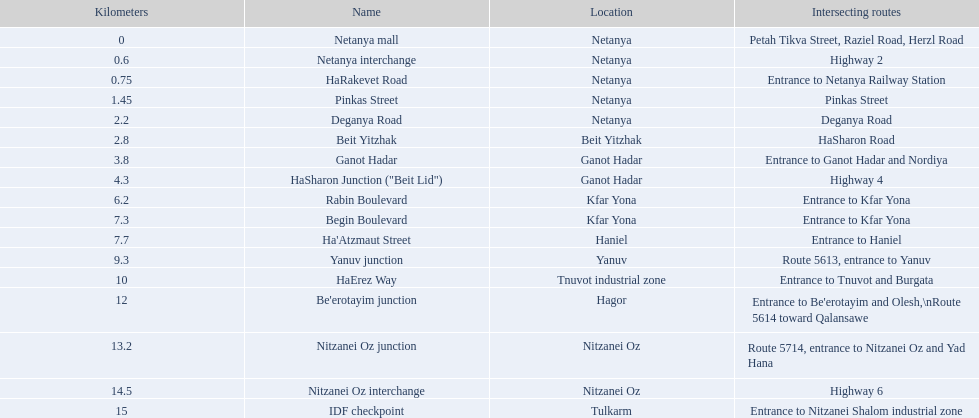Which part has the greatest length? IDF checkpoint. Would you be able to parse every entry in this table? {'header': ['Kilometers', 'Name', 'Location', 'Intersecting routes'], 'rows': [['0', 'Netanya mall', 'Netanya', 'Petah Tikva Street, Raziel Road, Herzl Road'], ['0.6', 'Netanya interchange', 'Netanya', 'Highway 2'], ['0.75', 'HaRakevet Road', 'Netanya', 'Entrance to Netanya Railway Station'], ['1.45', 'Pinkas Street', 'Netanya', 'Pinkas Street'], ['2.2', 'Deganya Road', 'Netanya', 'Deganya Road'], ['2.8', 'Beit Yitzhak', 'Beit Yitzhak', 'HaSharon Road'], ['3.8', 'Ganot Hadar', 'Ganot Hadar', 'Entrance to Ganot Hadar and Nordiya'], ['4.3', 'HaSharon Junction ("Beit Lid")', 'Ganot Hadar', 'Highway 4'], ['6.2', 'Rabin Boulevard', 'Kfar Yona', 'Entrance to Kfar Yona'], ['7.3', 'Begin Boulevard', 'Kfar Yona', 'Entrance to Kfar Yona'], ['7.7', "Ha'Atzmaut Street", 'Haniel', 'Entrance to Haniel'], ['9.3', 'Yanuv junction', 'Yanuv', 'Route 5613, entrance to Yanuv'], ['10', 'HaErez Way', 'Tnuvot industrial zone', 'Entrance to Tnuvot and Burgata'], ['12', "Be'erotayim junction", 'Hagor', "Entrance to Be'erotayim and Olesh,\\nRoute 5614 toward Qalansawe"], ['13.2', 'Nitzanei Oz junction', 'Nitzanei Oz', 'Route 5714, entrance to Nitzanei Oz and Yad Hana'], ['14.5', 'Nitzanei Oz interchange', 'Nitzanei Oz', 'Highway 6'], ['15', 'IDF checkpoint', 'Tulkarm', 'Entrance to Nitzanei Shalom industrial zone']]} 